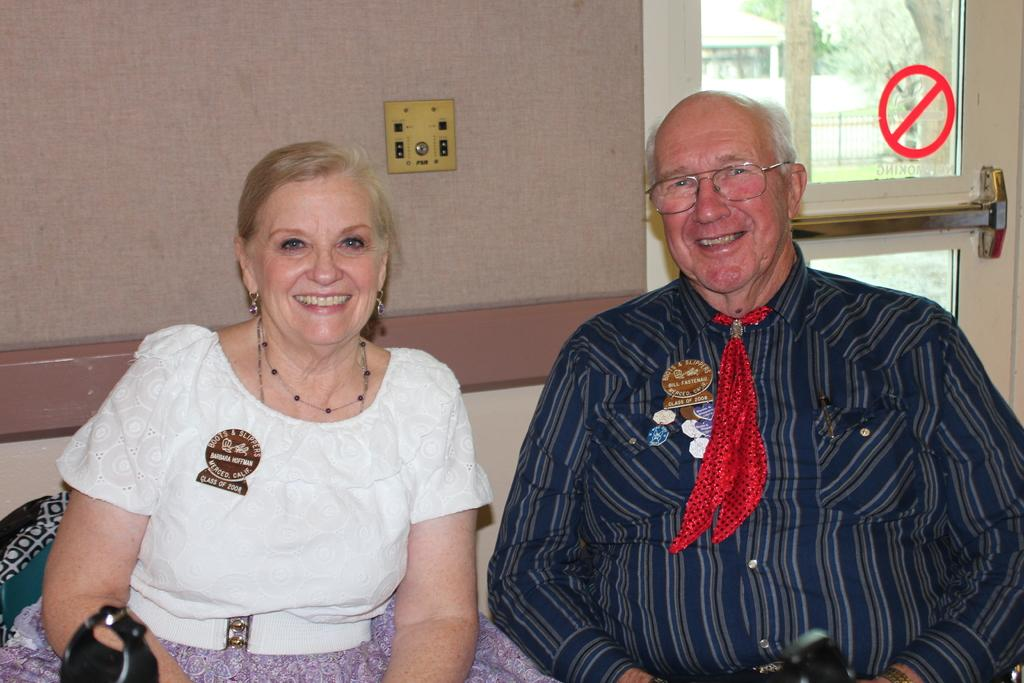How many people are in the image? There are two people in the image, a man and a woman. What are the positions of the man and woman in the image? The man is sitting, and the woman is sitting. What can be seen on the man's face? The man is wearing glasses. What is visible in the background of the image? There is a wall in the background of the image. What is the purpose of the sign mark on the glass door? The purpose of the sign mark on the glass door is not specified in the image. How many cushions are on the floor in the image? There are no cushions visible on the floor in the image. What type of balls are being used by the man and woman in the image? There are no balls present in the image. 